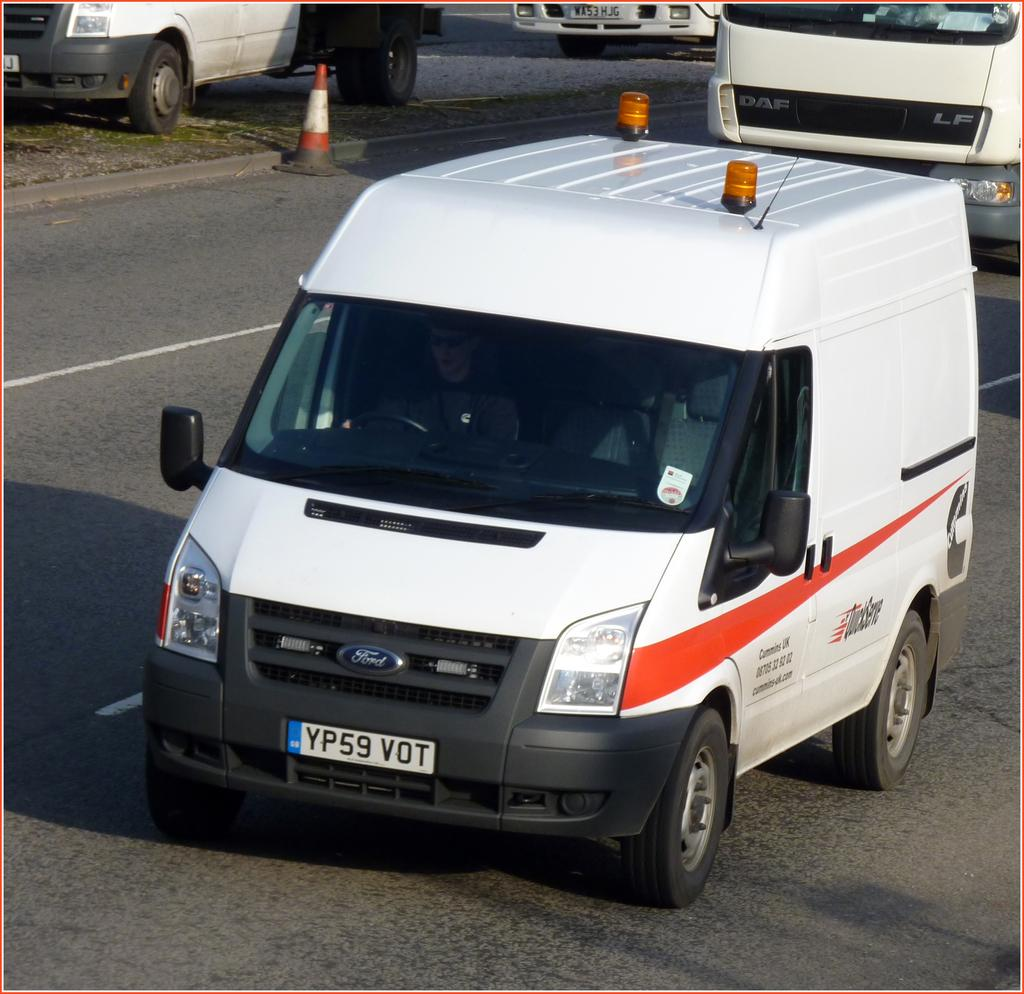Provide a one-sentence caption for the provided image. A Ford van with QuickServe on the side and plate number YP59 VOT. 